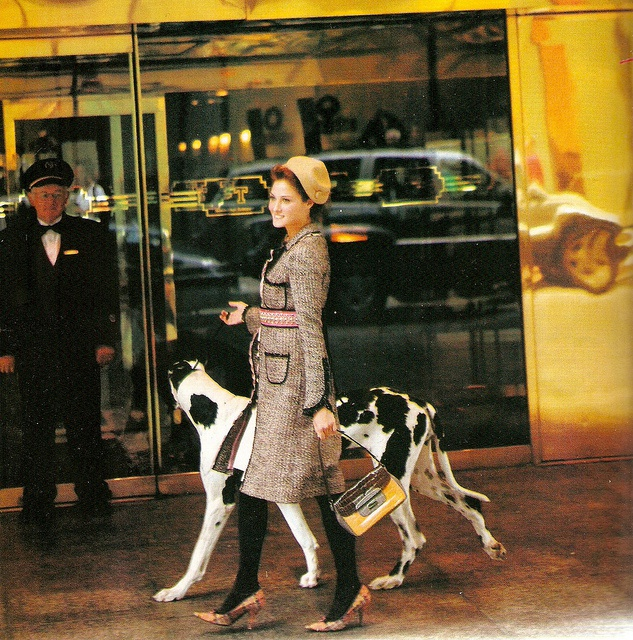Describe the objects in this image and their specific colors. I can see people in orange, black, gray, and tan tones, dog in orange, ivory, black, and tan tones, people in orange, black, maroon, and brown tones, car in orange, black, gray, darkgreen, and darkgray tones, and handbag in orange, black, maroon, and gray tones in this image. 